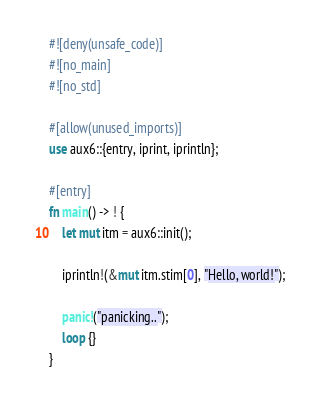<code> <loc_0><loc_0><loc_500><loc_500><_Rust_>#![deny(unsafe_code)]
#![no_main]
#![no_std]

#[allow(unused_imports)]
use aux6::{entry, iprint, iprintln};

#[entry]
fn main() -> ! {
    let mut itm = aux6::init();

    iprintln!(&mut itm.stim[0], "Hello, world!");

    panic!("panicking..");
    loop {}
}
</code> 